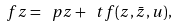<formula> <loc_0><loc_0><loc_500><loc_500>\ f z = \ p z + \ t f ( z , \bar { z } , u ) ,</formula> 